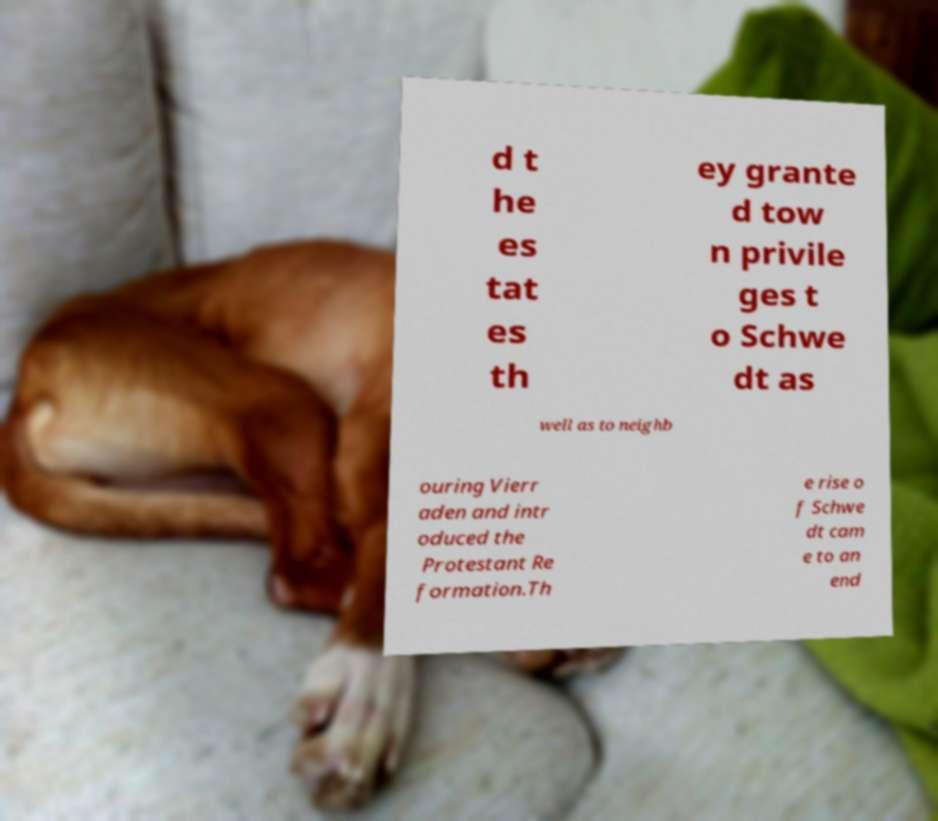Could you assist in decoding the text presented in this image and type it out clearly? d t he es tat es th ey grante d tow n privile ges t o Schwe dt as well as to neighb ouring Vierr aden and intr oduced the Protestant Re formation.Th e rise o f Schwe dt cam e to an end 